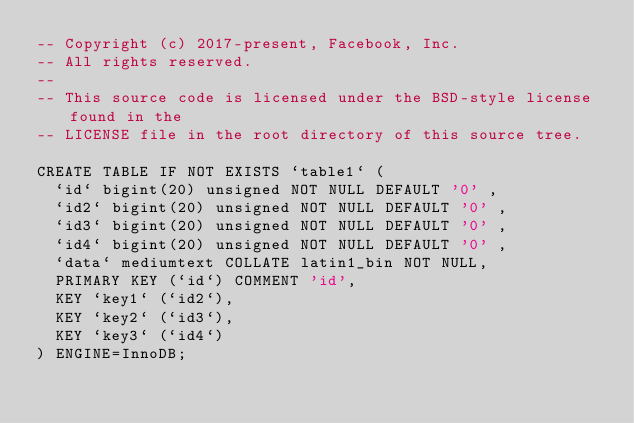Convert code to text. <code><loc_0><loc_0><loc_500><loc_500><_SQL_>-- Copyright (c) 2017-present, Facebook, Inc.
-- All rights reserved.
-- 
-- This source code is licensed under the BSD-style license found in the
-- LICENSE file in the root directory of this source tree.

CREATE TABLE IF NOT EXISTS `table1` (
  `id` bigint(20) unsigned NOT NULL DEFAULT '0' ,
  `id2` bigint(20) unsigned NOT NULL DEFAULT '0' ,
  `id3` bigint(20) unsigned NOT NULL DEFAULT '0' ,
  `id4` bigint(20) unsigned NOT NULL DEFAULT '0' ,
  `data` mediumtext COLLATE latin1_bin NOT NULL,
  PRIMARY KEY (`id`) COMMENT 'id',
  KEY `key1` (`id2`),
  KEY `key2` (`id3`),
  KEY `key3` (`id4`)
) ENGINE=InnoDB;
</code> 